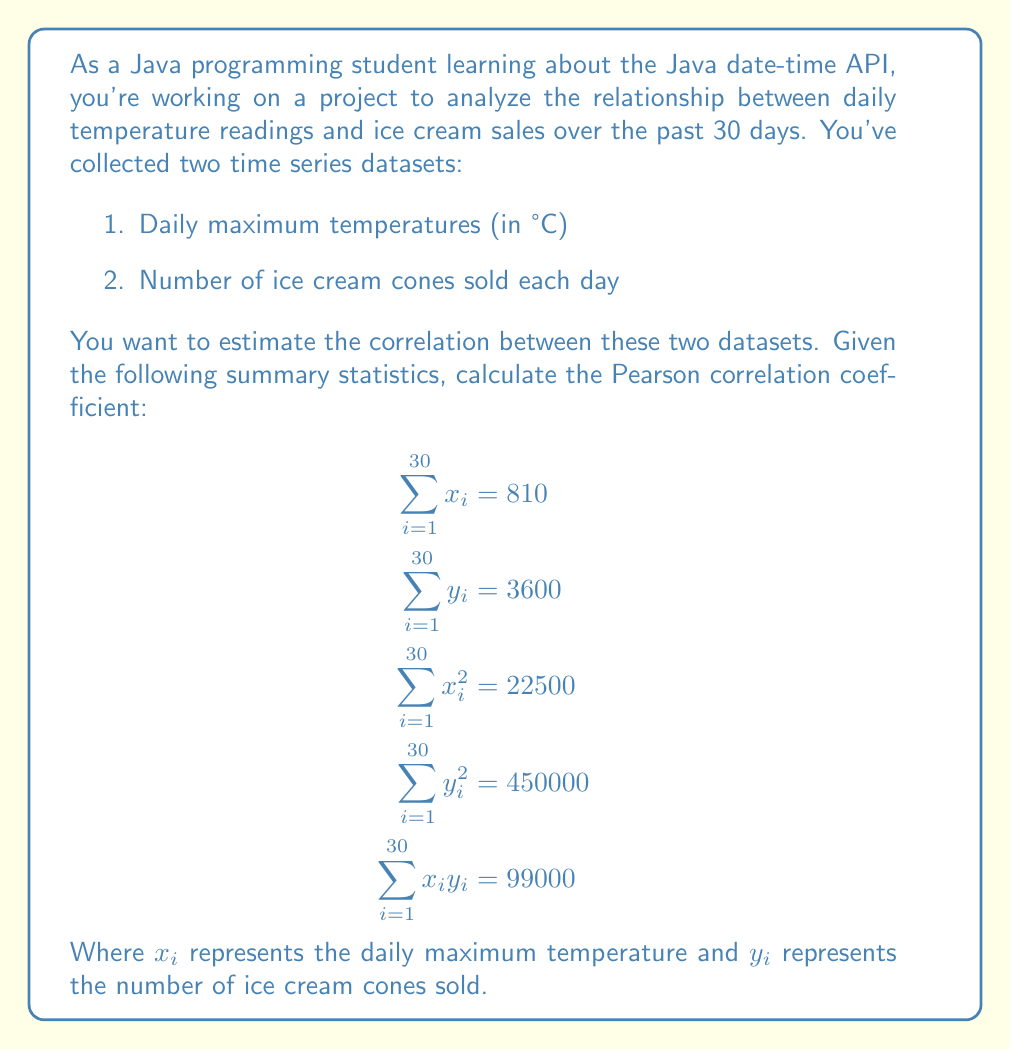Show me your answer to this math problem. To calculate the Pearson correlation coefficient, we'll use the formula:

$$r = \frac{n\sum x_iy_i - \sum x_i \sum y_i}{\sqrt{[n\sum x_i^2 - (\sum x_i)^2][n\sum y_i^2 - (\sum y_i)^2]}}$$

Where $n$ is the number of data points (30 in this case).

Let's substitute the given values and solve step by step:

1. Calculate $n\sum x_iy_i$:
   $30 \times 99000 = 2970000$

2. Calculate $\sum x_i \sum y_i$:
   $810 \times 3600 = 2916000$

3. Calculate the numerator:
   $2970000 - 2916000 = 54000$

4. Calculate $n\sum x_i^2$:
   $30 \times 22500 = 675000$

5. Calculate $(\sum x_i)^2$:
   $810^2 = 656100$

6. Calculate $n\sum y_i^2$:
   $30 \times 450000 = 13500000$

7. Calculate $(\sum y_i)^2$:
   $3600^2 = 12960000$

8. Calculate the denominator:
   $\sqrt{(675000 - 656100)(13500000 - 12960000)}$
   $= \sqrt{(18900)(540000)}$
   $= \sqrt{10206000000}$
   $= 101025$

9. Finally, calculate $r$:
   $r = \frac{54000}{101025} \approx 0.5345$
Answer: The Pearson correlation coefficient between daily maximum temperatures and ice cream sales is approximately 0.5345, indicating a moderate positive correlation. 